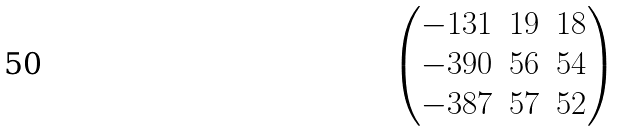Convert formula to latex. <formula><loc_0><loc_0><loc_500><loc_500>\begin{pmatrix} - 1 3 1 & 1 9 & 1 8 \\ - 3 9 0 & 5 6 & 5 4 \\ - 3 8 7 & 5 7 & 5 2 \end{pmatrix}</formula> 